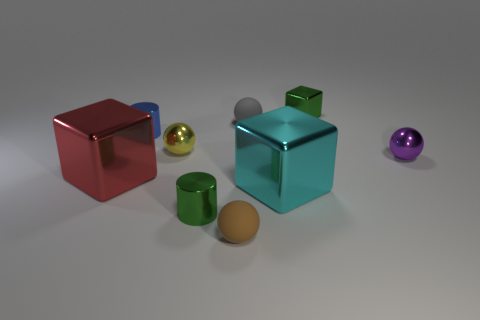Subtract all cylinders. How many objects are left? 7 Add 5 rubber objects. How many rubber objects are left? 7 Add 5 brown spheres. How many brown spheres exist? 6 Subtract 1 green cylinders. How many objects are left? 8 Subtract all tiny red rubber things. Subtract all small spheres. How many objects are left? 5 